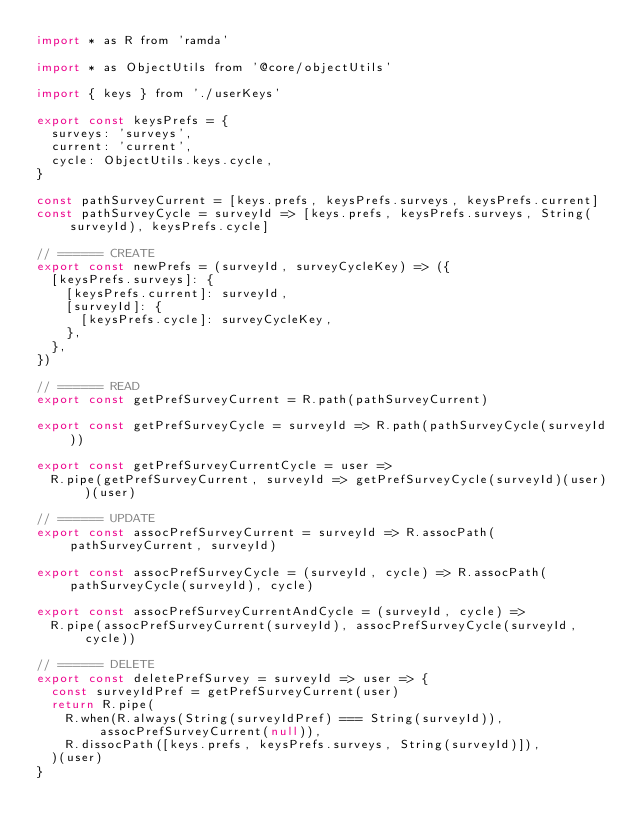<code> <loc_0><loc_0><loc_500><loc_500><_JavaScript_>import * as R from 'ramda'

import * as ObjectUtils from '@core/objectUtils'

import { keys } from './userKeys'

export const keysPrefs = {
  surveys: 'surveys',
  current: 'current',
  cycle: ObjectUtils.keys.cycle,
}

const pathSurveyCurrent = [keys.prefs, keysPrefs.surveys, keysPrefs.current]
const pathSurveyCycle = surveyId => [keys.prefs, keysPrefs.surveys, String(surveyId), keysPrefs.cycle]

// ====== CREATE
export const newPrefs = (surveyId, surveyCycleKey) => ({
  [keysPrefs.surveys]: {
    [keysPrefs.current]: surveyId,
    [surveyId]: {
      [keysPrefs.cycle]: surveyCycleKey,
    },
  },
})

// ====== READ
export const getPrefSurveyCurrent = R.path(pathSurveyCurrent)

export const getPrefSurveyCycle = surveyId => R.path(pathSurveyCycle(surveyId))

export const getPrefSurveyCurrentCycle = user =>
  R.pipe(getPrefSurveyCurrent, surveyId => getPrefSurveyCycle(surveyId)(user))(user)

// ====== UPDATE
export const assocPrefSurveyCurrent = surveyId => R.assocPath(pathSurveyCurrent, surveyId)

export const assocPrefSurveyCycle = (surveyId, cycle) => R.assocPath(pathSurveyCycle(surveyId), cycle)

export const assocPrefSurveyCurrentAndCycle = (surveyId, cycle) =>
  R.pipe(assocPrefSurveyCurrent(surveyId), assocPrefSurveyCycle(surveyId, cycle))

// ====== DELETE
export const deletePrefSurvey = surveyId => user => {
  const surveyIdPref = getPrefSurveyCurrent(user)
  return R.pipe(
    R.when(R.always(String(surveyIdPref) === String(surveyId)), assocPrefSurveyCurrent(null)),
    R.dissocPath([keys.prefs, keysPrefs.surveys, String(surveyId)]),
  )(user)
}
</code> 